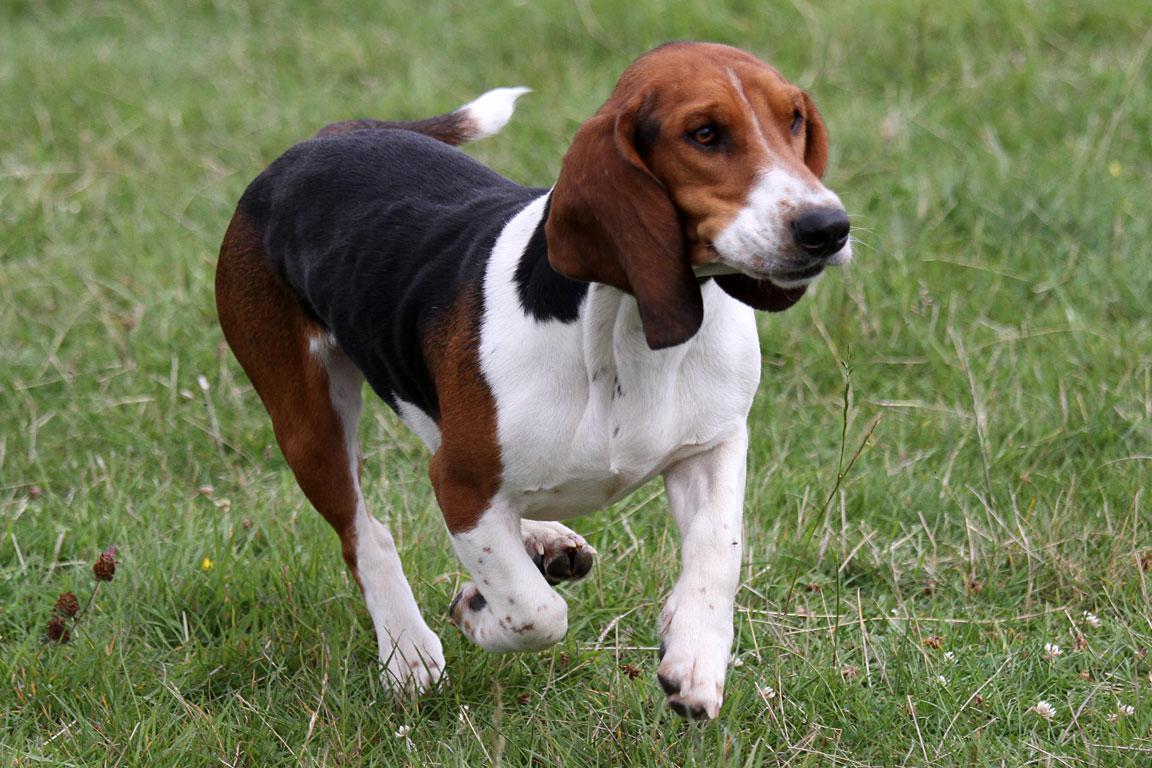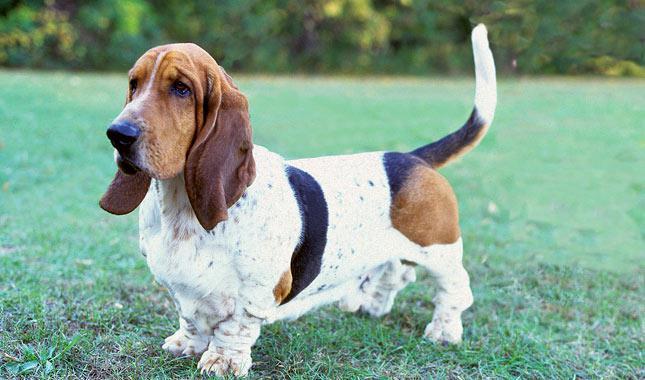The first image is the image on the left, the second image is the image on the right. Given the left and right images, does the statement "There are two dogs in the image pair." hold true? Answer yes or no. Yes. 